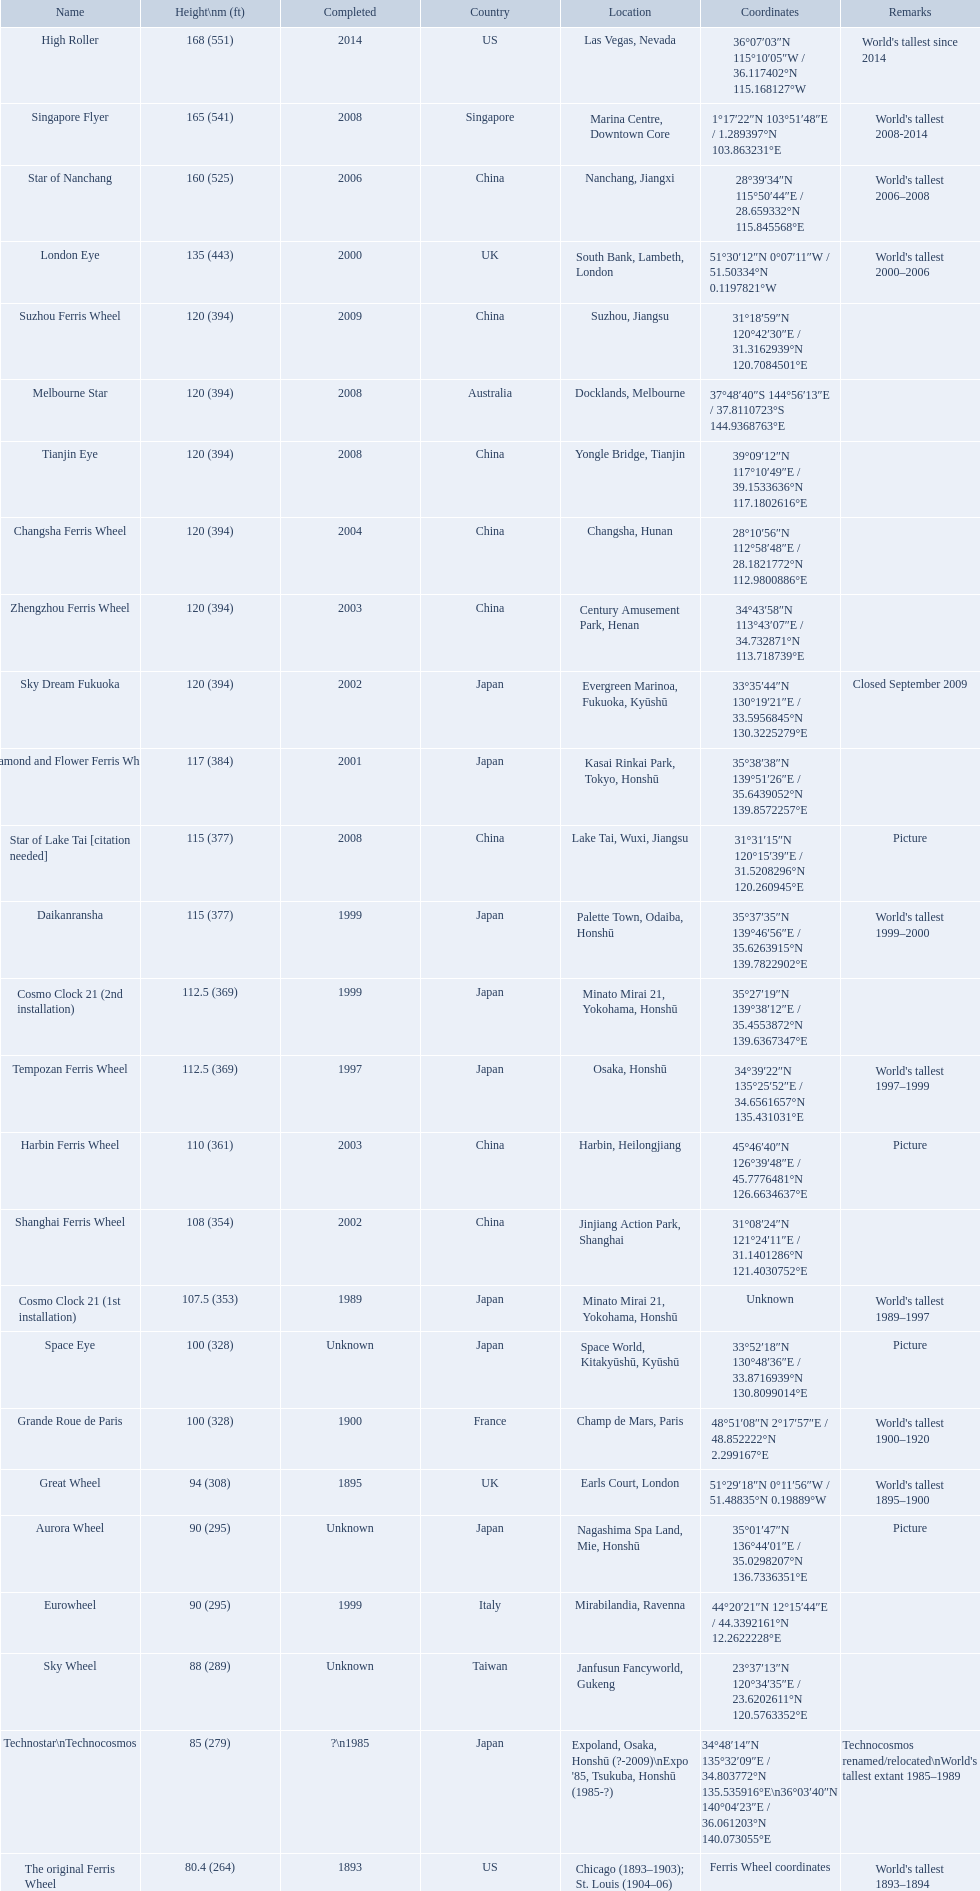When was the high roller ferris wheel completed? 2014. Which ferris wheel was completed in 2006? Star of Nanchang. Which one was completed in 2008? Singapore Flyer. What ferris wheels were completed in 2008 Singapore Flyer, Melbourne Star, Tianjin Eye, Star of Lake Tai [citation needed]. Of these, which has the height of 165? Singapore Flyer. What are the different completion dates for the ferris wheel list? 2014, 2008, 2006, 2000, 2009, 2008, 2008, 2004, 2003, 2002, 2001, 2008, 1999, 1999, 1997, 2003, 2002, 1989, Unknown, 1900, 1895, Unknown, 1999, Unknown, ?\n1985, 1893. Which dates for the star of lake tai, star of nanchang, melbourne star? 2006, 2008, 2008. Which is the oldest? 2006. What ride name is this for? Star of Nanchang. What are all of the ferris wheels? High Roller, Singapore Flyer, Star of Nanchang, London Eye, Suzhou Ferris Wheel, Melbourne Star, Tianjin Eye, Changsha Ferris Wheel, Zhengzhou Ferris Wheel, Sky Dream Fukuoka, Diamond and Flower Ferris Wheel, Star of Lake Tai [citation needed], Daikanransha, Cosmo Clock 21 (2nd installation), Tempozan Ferris Wheel, Harbin Ferris Wheel, Shanghai Ferris Wheel, Cosmo Clock 21 (1st installation), Space Eye, Grande Roue de Paris, Great Wheel, Aurora Wheel, Eurowheel, Sky Wheel, Technostar\nTechnocosmos, The original Ferris Wheel. And when were they completed? 2014, 2008, 2006, 2000, 2009, 2008, 2008, 2004, 2003, 2002, 2001, 2008, 1999, 1999, 1997, 2003, 2002, 1989, Unknown, 1900, 1895, Unknown, 1999, Unknown, ?\n1985, 1893. And among star of lake tai, star of nanchang, and melbourne star, which ferris wheel is oldest? Star of Nanchang. When was the high roller ferris wheel construction completed? 2014. Write the full table. {'header': ['Name', 'Height\\nm (ft)', 'Completed', 'Country', 'Location', 'Coordinates', 'Remarks'], 'rows': [['High Roller', '168 (551)', '2014', 'US', 'Las Vegas, Nevada', '36°07′03″N 115°10′05″W\ufeff / \ufeff36.117402°N 115.168127°W', "World's tallest since 2014"], ['Singapore Flyer', '165 (541)', '2008', 'Singapore', 'Marina Centre, Downtown Core', '1°17′22″N 103°51′48″E\ufeff / \ufeff1.289397°N 103.863231°E', "World's tallest 2008-2014"], ['Star of Nanchang', '160 (525)', '2006', 'China', 'Nanchang, Jiangxi', '28°39′34″N 115°50′44″E\ufeff / \ufeff28.659332°N 115.845568°E', "World's tallest 2006–2008"], ['London Eye', '135 (443)', '2000', 'UK', 'South Bank, Lambeth, London', '51°30′12″N 0°07′11″W\ufeff / \ufeff51.50334°N 0.1197821°W', "World's tallest 2000–2006"], ['Suzhou Ferris Wheel', '120 (394)', '2009', 'China', 'Suzhou, Jiangsu', '31°18′59″N 120°42′30″E\ufeff / \ufeff31.3162939°N 120.7084501°E', ''], ['Melbourne Star', '120 (394)', '2008', 'Australia', 'Docklands, Melbourne', '37°48′40″S 144°56′13″E\ufeff / \ufeff37.8110723°S 144.9368763°E', ''], ['Tianjin Eye', '120 (394)', '2008', 'China', 'Yongle Bridge, Tianjin', '39°09′12″N 117°10′49″E\ufeff / \ufeff39.1533636°N 117.1802616°E', ''], ['Changsha Ferris Wheel', '120 (394)', '2004', 'China', 'Changsha, Hunan', '28°10′56″N 112°58′48″E\ufeff / \ufeff28.1821772°N 112.9800886°E', ''], ['Zhengzhou Ferris Wheel', '120 (394)', '2003', 'China', 'Century Amusement Park, Henan', '34°43′58″N 113°43′07″E\ufeff / \ufeff34.732871°N 113.718739°E', ''], ['Sky Dream Fukuoka', '120 (394)', '2002', 'Japan', 'Evergreen Marinoa, Fukuoka, Kyūshū', '33°35′44″N 130°19′21″E\ufeff / \ufeff33.5956845°N 130.3225279°E', 'Closed September 2009'], ['Diamond\xa0and\xa0Flower\xa0Ferris\xa0Wheel', '117 (384)', '2001', 'Japan', 'Kasai Rinkai Park, Tokyo, Honshū', '35°38′38″N 139°51′26″E\ufeff / \ufeff35.6439052°N 139.8572257°E', ''], ['Star of Lake Tai\xa0[citation needed]', '115 (377)', '2008', 'China', 'Lake Tai, Wuxi, Jiangsu', '31°31′15″N 120°15′39″E\ufeff / \ufeff31.5208296°N 120.260945°E', 'Picture'], ['Daikanransha', '115 (377)', '1999', 'Japan', 'Palette Town, Odaiba, Honshū', '35°37′35″N 139°46′56″E\ufeff / \ufeff35.6263915°N 139.7822902°E', "World's tallest 1999–2000"], ['Cosmo Clock 21 (2nd installation)', '112.5 (369)', '1999', 'Japan', 'Minato Mirai 21, Yokohama, Honshū', '35°27′19″N 139°38′12″E\ufeff / \ufeff35.4553872°N 139.6367347°E', ''], ['Tempozan Ferris Wheel', '112.5 (369)', '1997', 'Japan', 'Osaka, Honshū', '34°39′22″N 135°25′52″E\ufeff / \ufeff34.6561657°N 135.431031°E', "World's tallest 1997–1999"], ['Harbin Ferris Wheel', '110 (361)', '2003', 'China', 'Harbin, Heilongjiang', '45°46′40″N 126°39′48″E\ufeff / \ufeff45.7776481°N 126.6634637°E', 'Picture'], ['Shanghai Ferris Wheel', '108 (354)', '2002', 'China', 'Jinjiang Action Park, Shanghai', '31°08′24″N 121°24′11″E\ufeff / \ufeff31.1401286°N 121.4030752°E', ''], ['Cosmo Clock 21 (1st installation)', '107.5 (353)', '1989', 'Japan', 'Minato Mirai 21, Yokohama, Honshū', 'Unknown', "World's tallest 1989–1997"], ['Space Eye', '100 (328)', 'Unknown', 'Japan', 'Space World, Kitakyūshū, Kyūshū', '33°52′18″N 130°48′36″E\ufeff / \ufeff33.8716939°N 130.8099014°E', 'Picture'], ['Grande Roue de Paris', '100 (328)', '1900', 'France', 'Champ de Mars, Paris', '48°51′08″N 2°17′57″E\ufeff / \ufeff48.852222°N 2.299167°E', "World's tallest 1900–1920"], ['Great Wheel', '94 (308)', '1895', 'UK', 'Earls Court, London', '51°29′18″N 0°11′56″W\ufeff / \ufeff51.48835°N 0.19889°W', "World's tallest 1895–1900"], ['Aurora Wheel', '90 (295)', 'Unknown', 'Japan', 'Nagashima Spa Land, Mie, Honshū', '35°01′47″N 136°44′01″E\ufeff / \ufeff35.0298207°N 136.7336351°E', 'Picture'], ['Eurowheel', '90 (295)', '1999', 'Italy', 'Mirabilandia, Ravenna', '44°20′21″N 12°15′44″E\ufeff / \ufeff44.3392161°N 12.2622228°E', ''], ['Sky Wheel', '88 (289)', 'Unknown', 'Taiwan', 'Janfusun Fancyworld, Gukeng', '23°37′13″N 120°34′35″E\ufeff / \ufeff23.6202611°N 120.5763352°E', ''], ['Technostar\\nTechnocosmos', '85 (279)', '?\\n1985', 'Japan', "Expoland, Osaka, Honshū (?-2009)\\nExpo '85, Tsukuba, Honshū (1985-?)", '34°48′14″N 135°32′09″E\ufeff / \ufeff34.803772°N 135.535916°E\\n36°03′40″N 140°04′23″E\ufeff / \ufeff36.061203°N 140.073055°E', "Technocosmos renamed/relocated\\nWorld's tallest extant 1985–1989"], ['The original Ferris Wheel', '80.4 (264)', '1893', 'US', 'Chicago (1893–1903); St. Louis (1904–06)', 'Ferris Wheel coordinates', "World's tallest 1893–1894"]]} Which ferris wheel had its construction completed in 2006? Star of Nanchang. Which one had it completed in 2008? Singapore Flyer. What are the different names of all the ferris wheels? High Roller, Singapore Flyer, Star of Nanchang, London Eye, Suzhou Ferris Wheel, Melbourne Star, Tianjin Eye, Changsha Ferris Wheel, Zhengzhou Ferris Wheel, Sky Dream Fukuoka, Diamond and Flower Ferris Wheel, Star of Lake Tai [citation needed], Daikanransha, Cosmo Clock 21 (2nd installation), Tempozan Ferris Wheel, Harbin Ferris Wheel, Shanghai Ferris Wheel, Cosmo Clock 21 (1st installation), Space Eye, Grande Roue de Paris, Great Wheel, Aurora Wheel, Eurowheel, Sky Wheel, Technostar\nTechnocosmos, The original Ferris Wheel. What was their respective height? 168 (551), 165 (541), 160 (525), 135 (443), 120 (394), 120 (394), 120 (394), 120 (394), 120 (394), 120 (394), 117 (384), 115 (377), 115 (377), 112.5 (369), 112.5 (369), 110 (361), 108 (354), 107.5 (353), 100 (328), 100 (328), 94 (308), 90 (295), 90 (295), 88 (289), 85 (279), 80.4 (264). And when were they all completed? 2014, 2008, 2006, 2000, 2009, 2008, 2008, 2004, 2003, 2002, 2001, 2008, 1999, 1999, 1997, 2003, 2002, 1989, Unknown, 1900, 1895, Unknown, 1999, Unknown, ?\n1985, 1893. Which were accomplished in 2008? Singapore Flyer, Melbourne Star, Tianjin Eye, Star of Lake Tai [citation needed]. And of those ferris wheels, which reached a height of 165 meters? Singapore Flyer. Would you mind parsing the complete table? {'header': ['Name', 'Height\\nm (ft)', 'Completed', 'Country', 'Location', 'Coordinates', 'Remarks'], 'rows': [['High Roller', '168 (551)', '2014', 'US', 'Las Vegas, Nevada', '36°07′03″N 115°10′05″W\ufeff / \ufeff36.117402°N 115.168127°W', "World's tallest since 2014"], ['Singapore Flyer', '165 (541)', '2008', 'Singapore', 'Marina Centre, Downtown Core', '1°17′22″N 103°51′48″E\ufeff / \ufeff1.289397°N 103.863231°E', "World's tallest 2008-2014"], ['Star of Nanchang', '160 (525)', '2006', 'China', 'Nanchang, Jiangxi', '28°39′34″N 115°50′44″E\ufeff / \ufeff28.659332°N 115.845568°E', "World's tallest 2006–2008"], ['London Eye', '135 (443)', '2000', 'UK', 'South Bank, Lambeth, London', '51°30′12″N 0°07′11″W\ufeff / \ufeff51.50334°N 0.1197821°W', "World's tallest 2000–2006"], ['Suzhou Ferris Wheel', '120 (394)', '2009', 'China', 'Suzhou, Jiangsu', '31°18′59″N 120°42′30″E\ufeff / \ufeff31.3162939°N 120.7084501°E', ''], ['Melbourne Star', '120 (394)', '2008', 'Australia', 'Docklands, Melbourne', '37°48′40″S 144°56′13″E\ufeff / \ufeff37.8110723°S 144.9368763°E', ''], ['Tianjin Eye', '120 (394)', '2008', 'China', 'Yongle Bridge, Tianjin', '39°09′12″N 117°10′49″E\ufeff / \ufeff39.1533636°N 117.1802616°E', ''], ['Changsha Ferris Wheel', '120 (394)', '2004', 'China', 'Changsha, Hunan', '28°10′56″N 112°58′48″E\ufeff / \ufeff28.1821772°N 112.9800886°E', ''], ['Zhengzhou Ferris Wheel', '120 (394)', '2003', 'China', 'Century Amusement Park, Henan', '34°43′58″N 113°43′07″E\ufeff / \ufeff34.732871°N 113.718739°E', ''], ['Sky Dream Fukuoka', '120 (394)', '2002', 'Japan', 'Evergreen Marinoa, Fukuoka, Kyūshū', '33°35′44″N 130°19′21″E\ufeff / \ufeff33.5956845°N 130.3225279°E', 'Closed September 2009'], ['Diamond\xa0and\xa0Flower\xa0Ferris\xa0Wheel', '117 (384)', '2001', 'Japan', 'Kasai Rinkai Park, Tokyo, Honshū', '35°38′38″N 139°51′26″E\ufeff / \ufeff35.6439052°N 139.8572257°E', ''], ['Star of Lake Tai\xa0[citation needed]', '115 (377)', '2008', 'China', 'Lake Tai, Wuxi, Jiangsu', '31°31′15″N 120°15′39″E\ufeff / \ufeff31.5208296°N 120.260945°E', 'Picture'], ['Daikanransha', '115 (377)', '1999', 'Japan', 'Palette Town, Odaiba, Honshū', '35°37′35″N 139°46′56″E\ufeff / \ufeff35.6263915°N 139.7822902°E', "World's tallest 1999–2000"], ['Cosmo Clock 21 (2nd installation)', '112.5 (369)', '1999', 'Japan', 'Minato Mirai 21, Yokohama, Honshū', '35°27′19″N 139°38′12″E\ufeff / \ufeff35.4553872°N 139.6367347°E', ''], ['Tempozan Ferris Wheel', '112.5 (369)', '1997', 'Japan', 'Osaka, Honshū', '34°39′22″N 135°25′52″E\ufeff / \ufeff34.6561657°N 135.431031°E', "World's tallest 1997–1999"], ['Harbin Ferris Wheel', '110 (361)', '2003', 'China', 'Harbin, Heilongjiang', '45°46′40″N 126°39′48″E\ufeff / \ufeff45.7776481°N 126.6634637°E', 'Picture'], ['Shanghai Ferris Wheel', '108 (354)', '2002', 'China', 'Jinjiang Action Park, Shanghai', '31°08′24″N 121°24′11″E\ufeff / \ufeff31.1401286°N 121.4030752°E', ''], ['Cosmo Clock 21 (1st installation)', '107.5 (353)', '1989', 'Japan', 'Minato Mirai 21, Yokohama, Honshū', 'Unknown', "World's tallest 1989–1997"], ['Space Eye', '100 (328)', 'Unknown', 'Japan', 'Space World, Kitakyūshū, Kyūshū', '33°52′18″N 130°48′36″E\ufeff / \ufeff33.8716939°N 130.8099014°E', 'Picture'], ['Grande Roue de Paris', '100 (328)', '1900', 'France', 'Champ de Mars, Paris', '48°51′08″N 2°17′57″E\ufeff / \ufeff48.852222°N 2.299167°E', "World's tallest 1900–1920"], ['Great Wheel', '94 (308)', '1895', 'UK', 'Earls Court, London', '51°29′18″N 0°11′56″W\ufeff / \ufeff51.48835°N 0.19889°W', "World's tallest 1895–1900"], ['Aurora Wheel', '90 (295)', 'Unknown', 'Japan', 'Nagashima Spa Land, Mie, Honshū', '35°01′47″N 136°44′01″E\ufeff / \ufeff35.0298207°N 136.7336351°E', 'Picture'], ['Eurowheel', '90 (295)', '1999', 'Italy', 'Mirabilandia, Ravenna', '44°20′21″N 12°15′44″E\ufeff / \ufeff44.3392161°N 12.2622228°E', ''], ['Sky Wheel', '88 (289)', 'Unknown', 'Taiwan', 'Janfusun Fancyworld, Gukeng', '23°37′13″N 120°34′35″E\ufeff / \ufeff23.6202611°N 120.5763352°E', ''], ['Technostar\\nTechnocosmos', '85 (279)', '?\\n1985', 'Japan', "Expoland, Osaka, Honshū (?-2009)\\nExpo '85, Tsukuba, Honshū (1985-?)", '34°48′14″N 135°32′09″E\ufeff / \ufeff34.803772°N 135.535916°E\\n36°03′40″N 140°04′23″E\ufeff / \ufeff36.061203°N 140.073055°E', "Technocosmos renamed/relocated\\nWorld's tallest extant 1985–1989"], ['The original Ferris Wheel', '80.4 (264)', '1893', 'US', 'Chicago (1893–1903); St. Louis (1904–06)', 'Ferris Wheel coordinates', "World's tallest 1893–1894"]]} What is the elevation of the roller coaster star of nanchang? 165 (541). When was the roller coaster star of nanchang finalized? 2008. What is the moniker of the earliest roller coaster? Star of Nanchang. What is the height of the roller coaster star of nanchang? 165 (541). When was the roller coaster star of nanchang finished? 2008. What is the title of the most ancient roller coaster? Star of Nanchang. When did the high roller ferris wheel reach completion? 2014. Which ferris wheel was brought to completion in 2006? Star of Nanchang. Which one was completed in 2008? Singapore Flyer. 